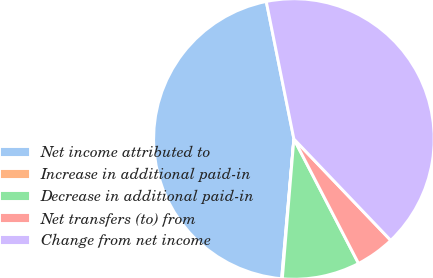Convert chart. <chart><loc_0><loc_0><loc_500><loc_500><pie_chart><fcel>Net income attributed to<fcel>Increase in additional paid-in<fcel>Decrease in additional paid-in<fcel>Net transfers (to) from<fcel>Change from net income<nl><fcel>45.45%<fcel>0.08%<fcel>8.94%<fcel>4.51%<fcel>41.02%<nl></chart> 